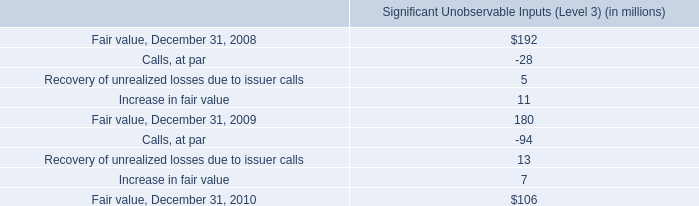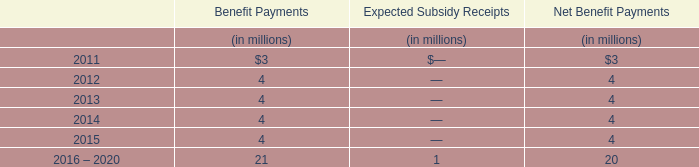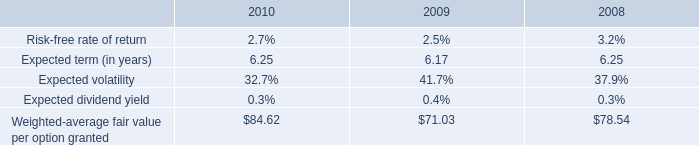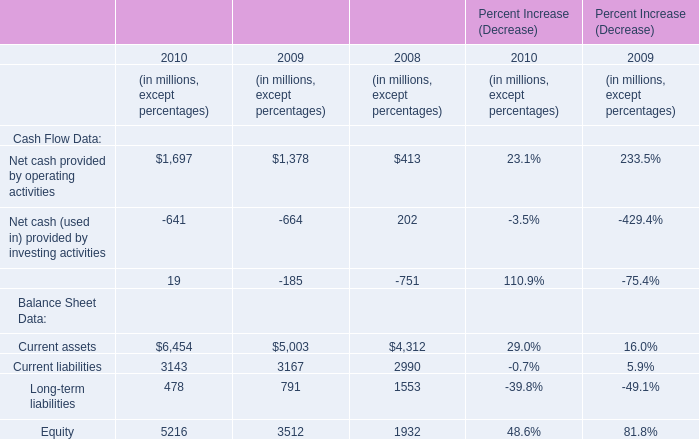In the year with largest amount of 2010, what's the increasing rate of Current assets? 
Computations: ((6454 - 5003) / 6454)
Answer: 0.22482. 